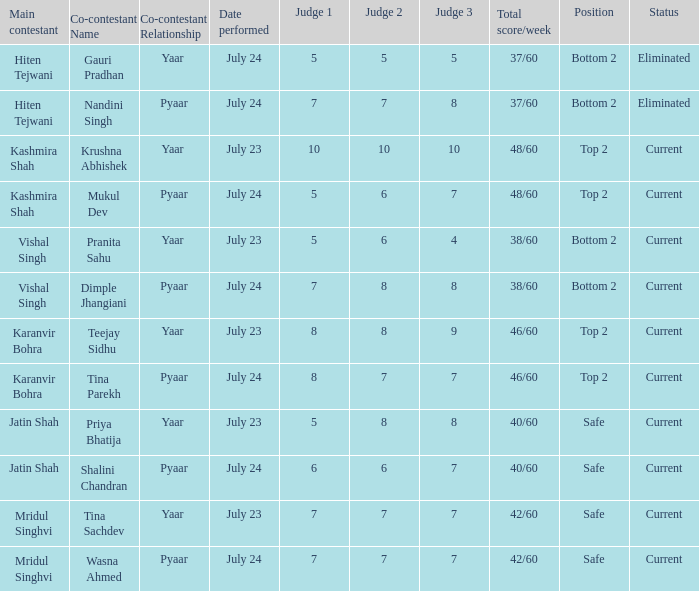What is Tina Sachdev's position? Safe. 